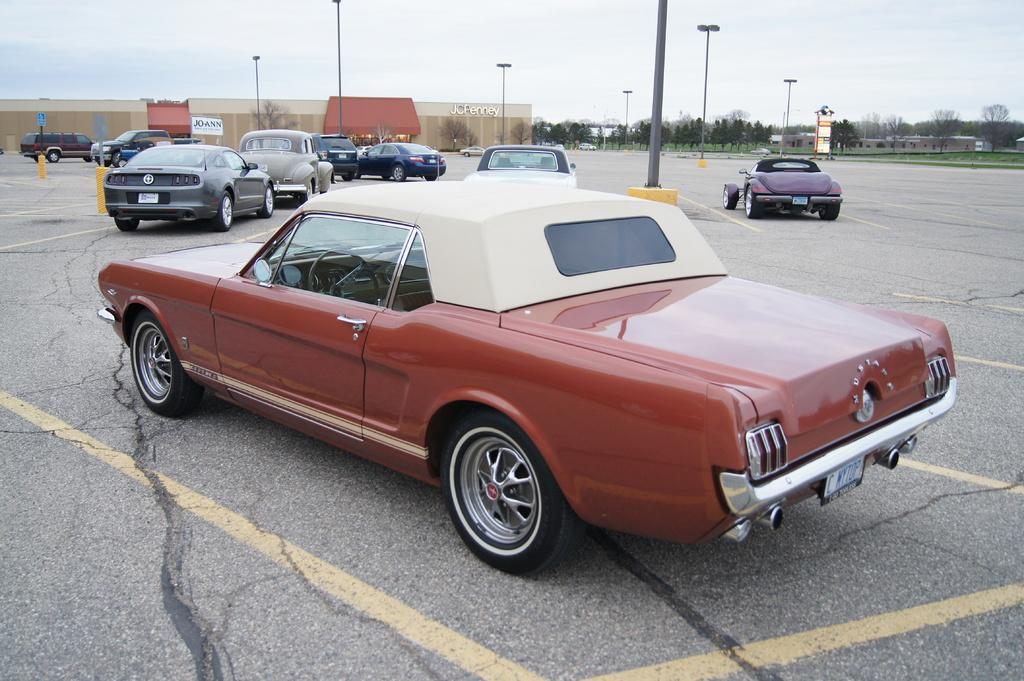What is the main subject of the picture? The main subject of the picture is a car. Are there any other cars visible in the image? Yes, there are other cars behind the first car. What can be seen on the left side of the image? There is a building on the left side of the image. What type of natural elements are present in the image? There are trees in the image. What type of man-made structures can be seen in the image? There are poles with lights in the image. How would you describe the weather based on the image? The sky is clear in the image, suggesting good weather. Can you tell me how many crows are sitting on the car in the image? There are no crows present in the image; it only features a car, other cars, a building, trees, poles with lights, and a clear sky. What type of structure is the car's engine connected to in the image? The image does not show the car's engine or any internal components, so it is not possible to determine what type of structure it might be connected to. 